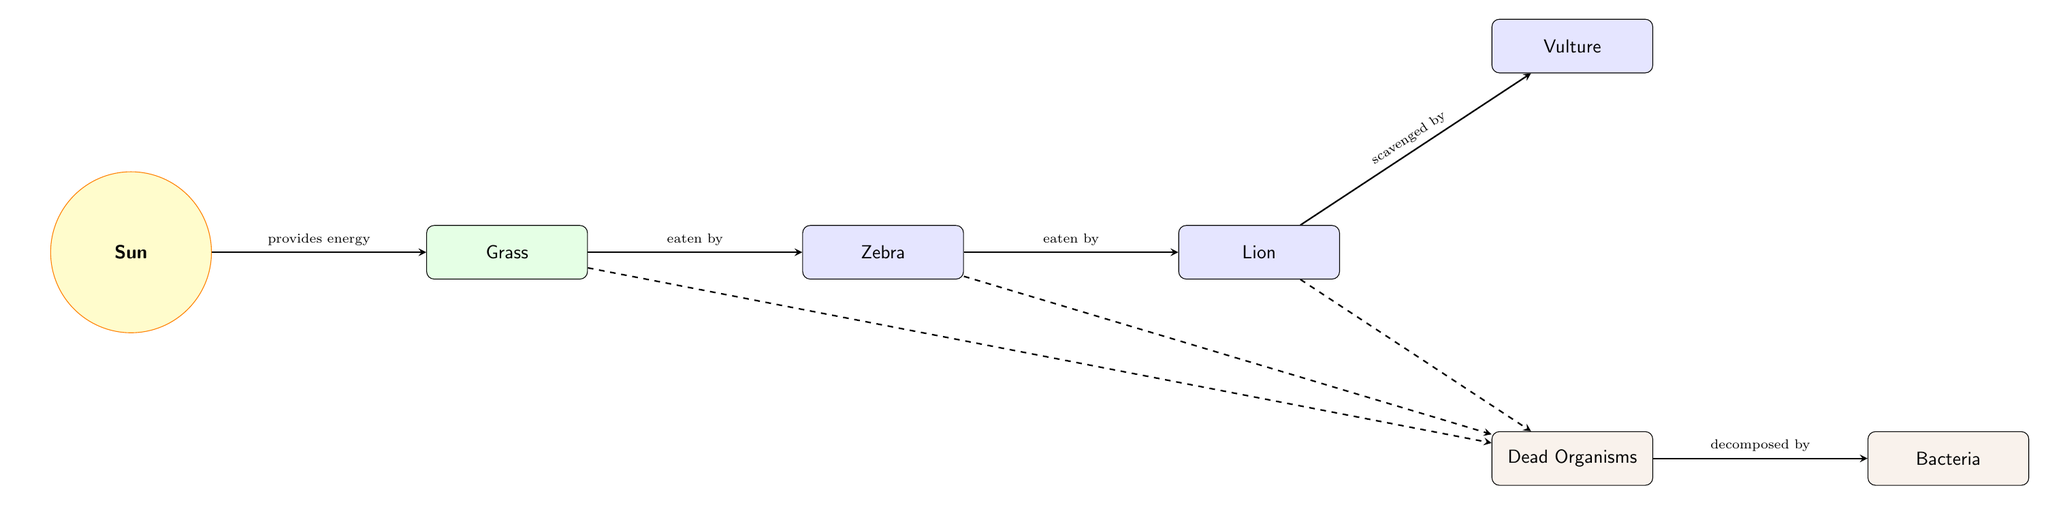What is the primary source of energy in this food chain? The diagram shows the sun as the initial node, indicating that it provides energy to the rest of the food chain. The connection from the sun to the grass demonstrates this flow of energy.
Answer: Sun Which organism is the primary producer in this food chain? The grass is depicted immediately after the sun in the food chain, meaning it is the first organism to convert sunlight into energy, qualifying it as the primary producer.
Answer: Grass How many consumers are present in this food chain? By counting the organisms classified as consumers, we find zebra, lion, and vulture, which totals three consumers.
Answer: 3 What is the relationship between the lion and the vulture? The diagram indicates that the lion is scavenged by the vulture, showing a predatory relationship where the vulture feeds on the remains of the lion's kills.
Answer: scavenged by Which process do bacteria perform on dead organisms? The diagram shows that bacteria decompose dead organisms, highlighting a key ecological role in recycling nutrients back into the ecosystem.
Answer: decomposed by If the zebra dies, what will happen to the energy it contained? When the zebra dies, it will become part of the dead organisms in the diagram, which indicates that it will eventually be decomposed by bacteria, redistributing its stored energy back into the ecosystem.
Answer: decomposed by bacteria 